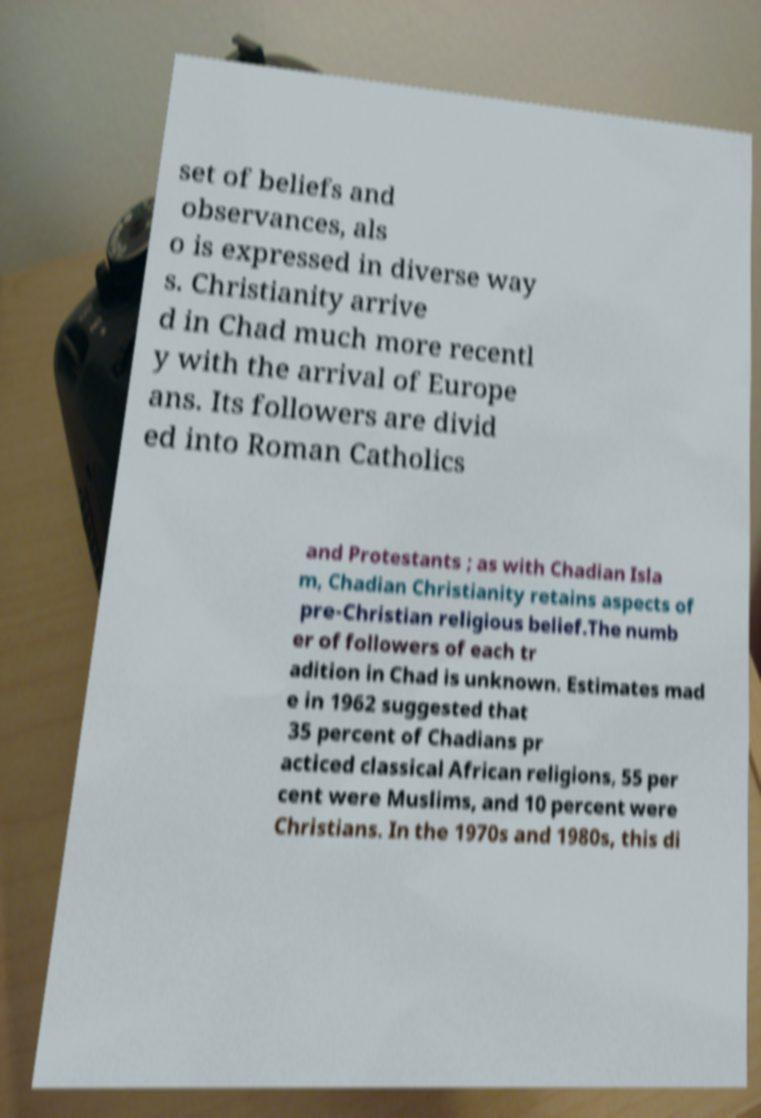Can you read and provide the text displayed in the image?This photo seems to have some interesting text. Can you extract and type it out for me? set of beliefs and observances, als o is expressed in diverse way s. Christianity arrive d in Chad much more recentl y with the arrival of Europe ans. Its followers are divid ed into Roman Catholics and Protestants ; as with Chadian Isla m, Chadian Christianity retains aspects of pre-Christian religious belief.The numb er of followers of each tr adition in Chad is unknown. Estimates mad e in 1962 suggested that 35 percent of Chadians pr acticed classical African religions, 55 per cent were Muslims, and 10 percent were Christians. In the 1970s and 1980s, this di 